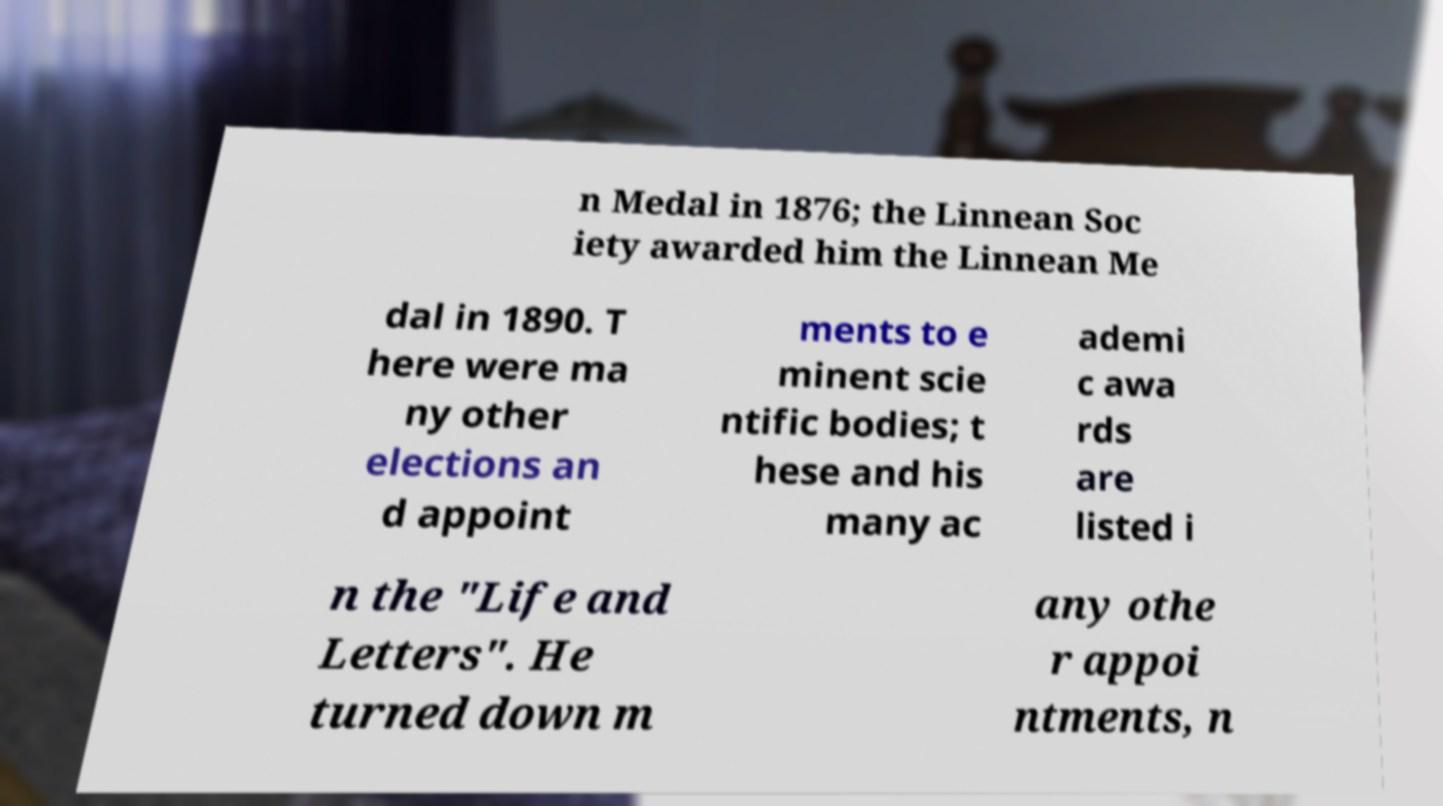Could you extract and type out the text from this image? n Medal in 1876; the Linnean Soc iety awarded him the Linnean Me dal in 1890. T here were ma ny other elections an d appoint ments to e minent scie ntific bodies; t hese and his many ac ademi c awa rds are listed i n the "Life and Letters". He turned down m any othe r appoi ntments, n 